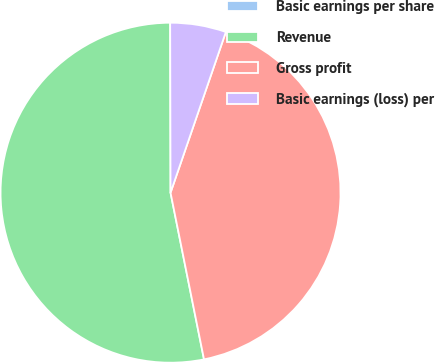Convert chart to OTSL. <chart><loc_0><loc_0><loc_500><loc_500><pie_chart><fcel>Basic earnings per share<fcel>Revenue<fcel>Gross profit<fcel>Basic earnings (loss) per<nl><fcel>0.0%<fcel>53.12%<fcel>41.57%<fcel>5.31%<nl></chart> 